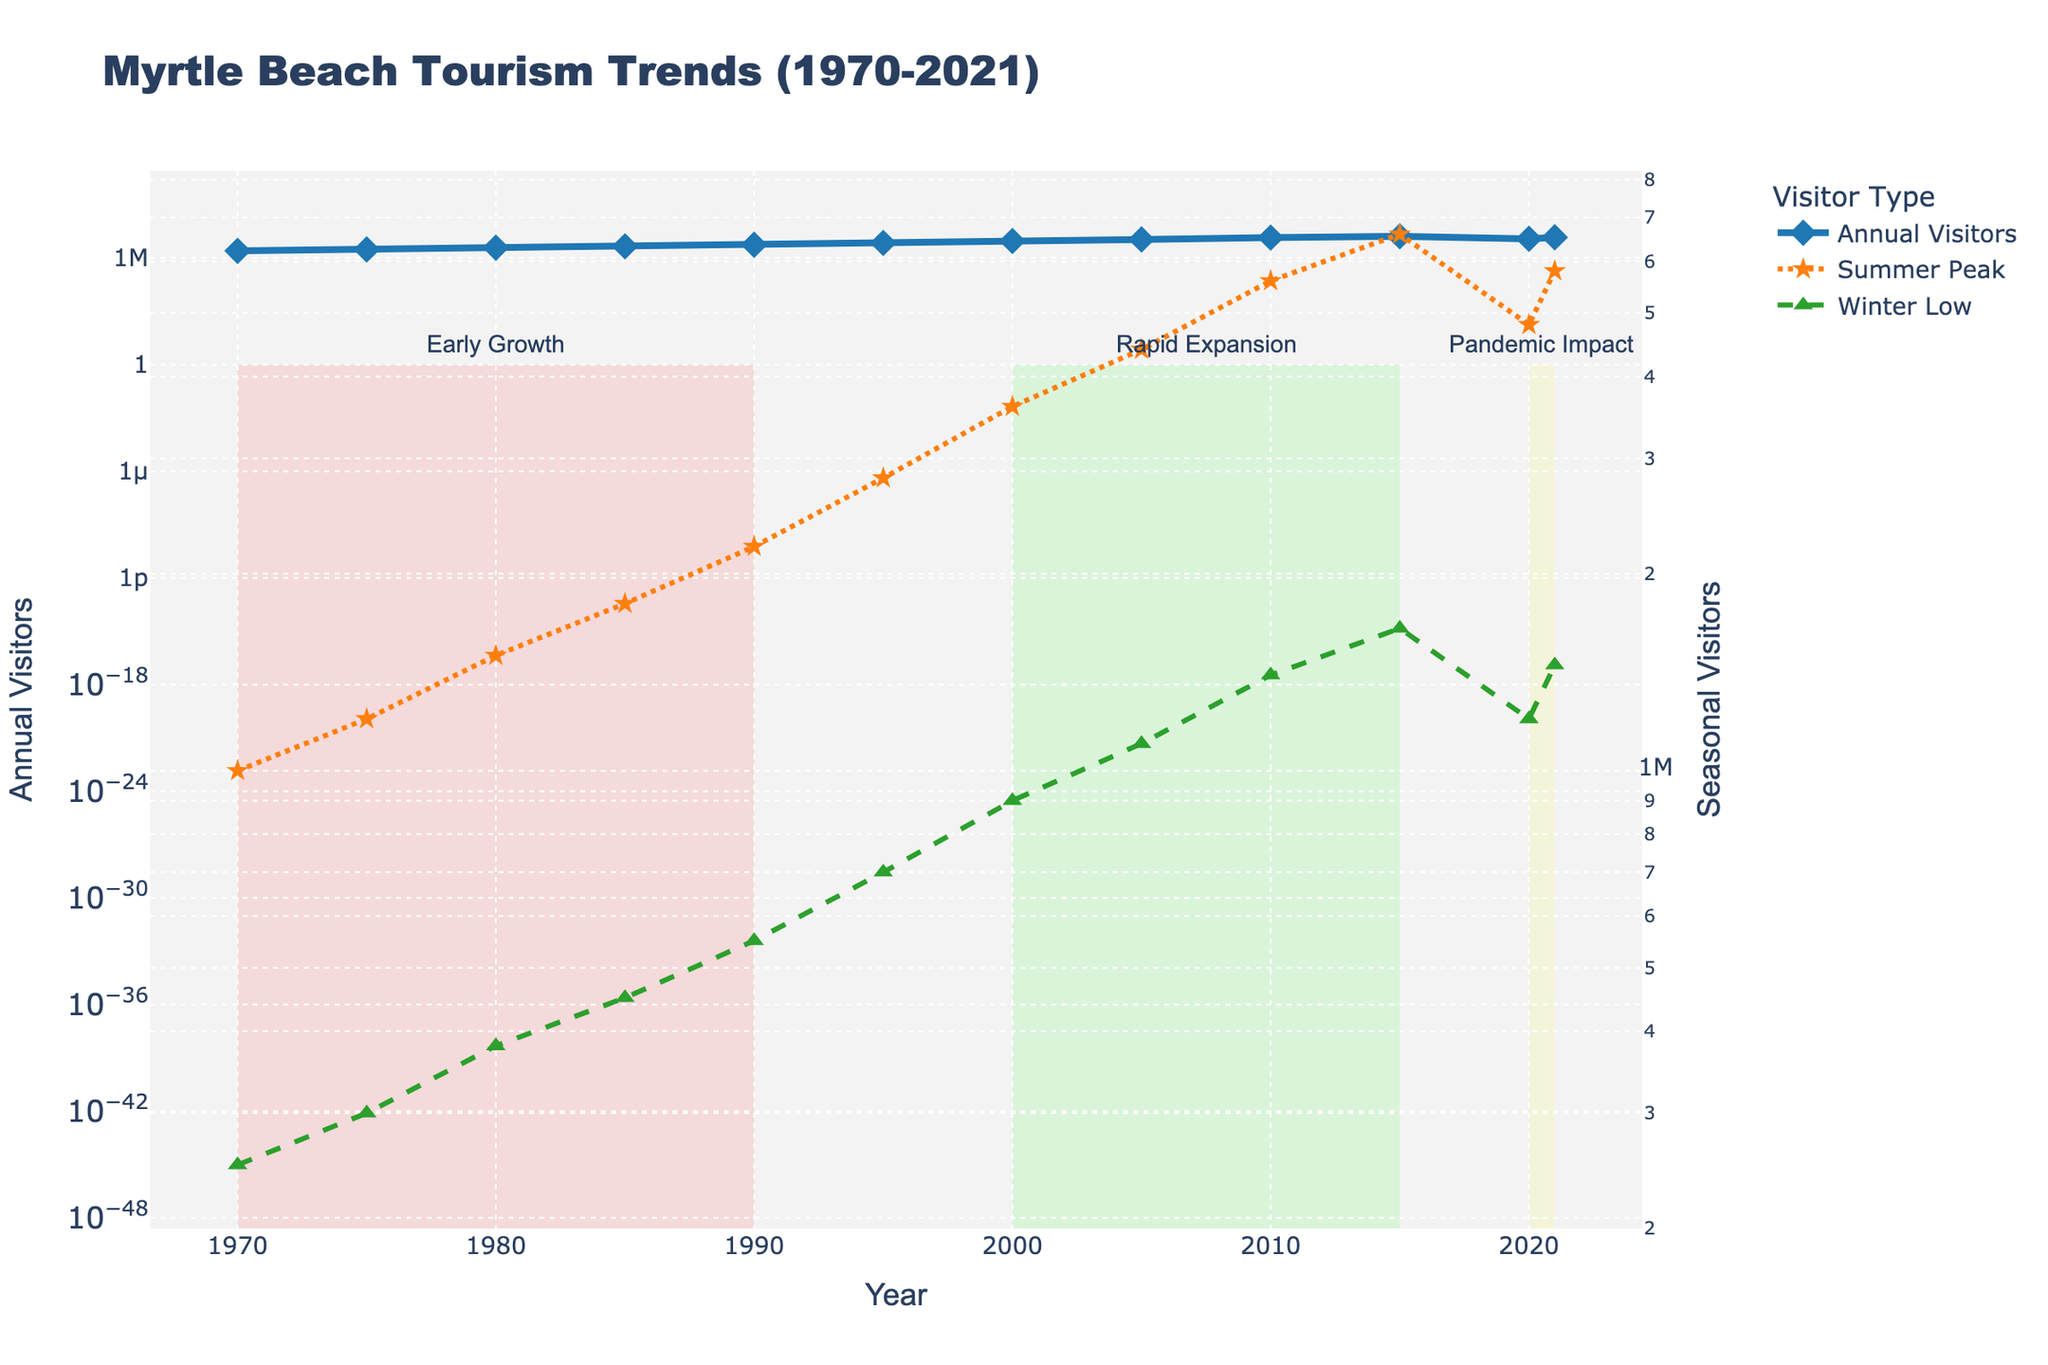What's the Summer Peak visitor count in the year 2000? To find the answer, locate the "Summer Peak" value on the chart corresponding to the year 2000, which is marked by orange dots and dashed lines.
Answer: 3,600,000 During which period did Myrtle Beach see an increase in Annual Visitors from 7 million to 11 million? Identify the "Annual Visitors" line marked in blue and locate the year range where the visitor count increased from 7 million to 11 million. The range is between 1995 and 2005.
Answer: 1995 to 2005 What's the difference in Winter Low visitor counts between the years 1990 and 2020? Locate the "Winter Low" trend marked by green dashed lines for the years 1990 and 2020. Subtract the 2020 value (1,200,000) from the 1990 value (550,000).
Answer: 650,000 Between what years did the "Rapid Expansion" of tourism occur according to the chart? Identify the section labeled "Rapid Expansion" highlighted in green between the vertical rectangles on the timeline.
Answer: 2000 to 2015 Which year saw a higher Summer Peak visitor count: 2010 or 2021? Compare the "Summer Peak" values for the years 2010 and 2021, which are marked with orange stars on the timeline.
Answer: 2021 What is the total count of visitors (Annual Visitors, Summer Peak, and Winter Low) for the year 1980? Add the corresponding values for Annual Visitors (3,800,000), Summer Peak (1,500,000), and Winter Low (380,000) from the year 1980.
Answer: 5,680,000 What's the overall trend in Annual Visitors from 1970 to 2021? Observe the "Annual Visitors" line from 1970 to 2021, which is indicated by a blue line with diamond markers. Note the general pattern of increase, the peak around 2015, a dip in 2020, and a slight recovery in 2021.
Answer: Increasing How did the Pandemic Impact affect Annual Visitors between 2020 and 2021? In the chart area labeled "Pandemic Impact" (yellow rectangle), compare Annual Visitors counts for 2020 and 2021. Notice a drop from 16.5 million to 12 million in 2020, followed by a recovery to 14.5 million in 2021.
Answer: Decline then recovery What is the average Winter Low visitor count from 1970 to 1990? Find the Winter Low values for the years 1970, 1975, 1980, 1985, and 1990, add them up (250,000+300,000+380,000+450,000+550,000) then divide by 5.
Answer: 386,000 